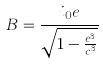<formula> <loc_0><loc_0><loc_500><loc_500>B = \frac { i _ { 0 } e } { \sqrt { 1 - \frac { e ^ { 3 } } { c ^ { 3 } } } }</formula> 